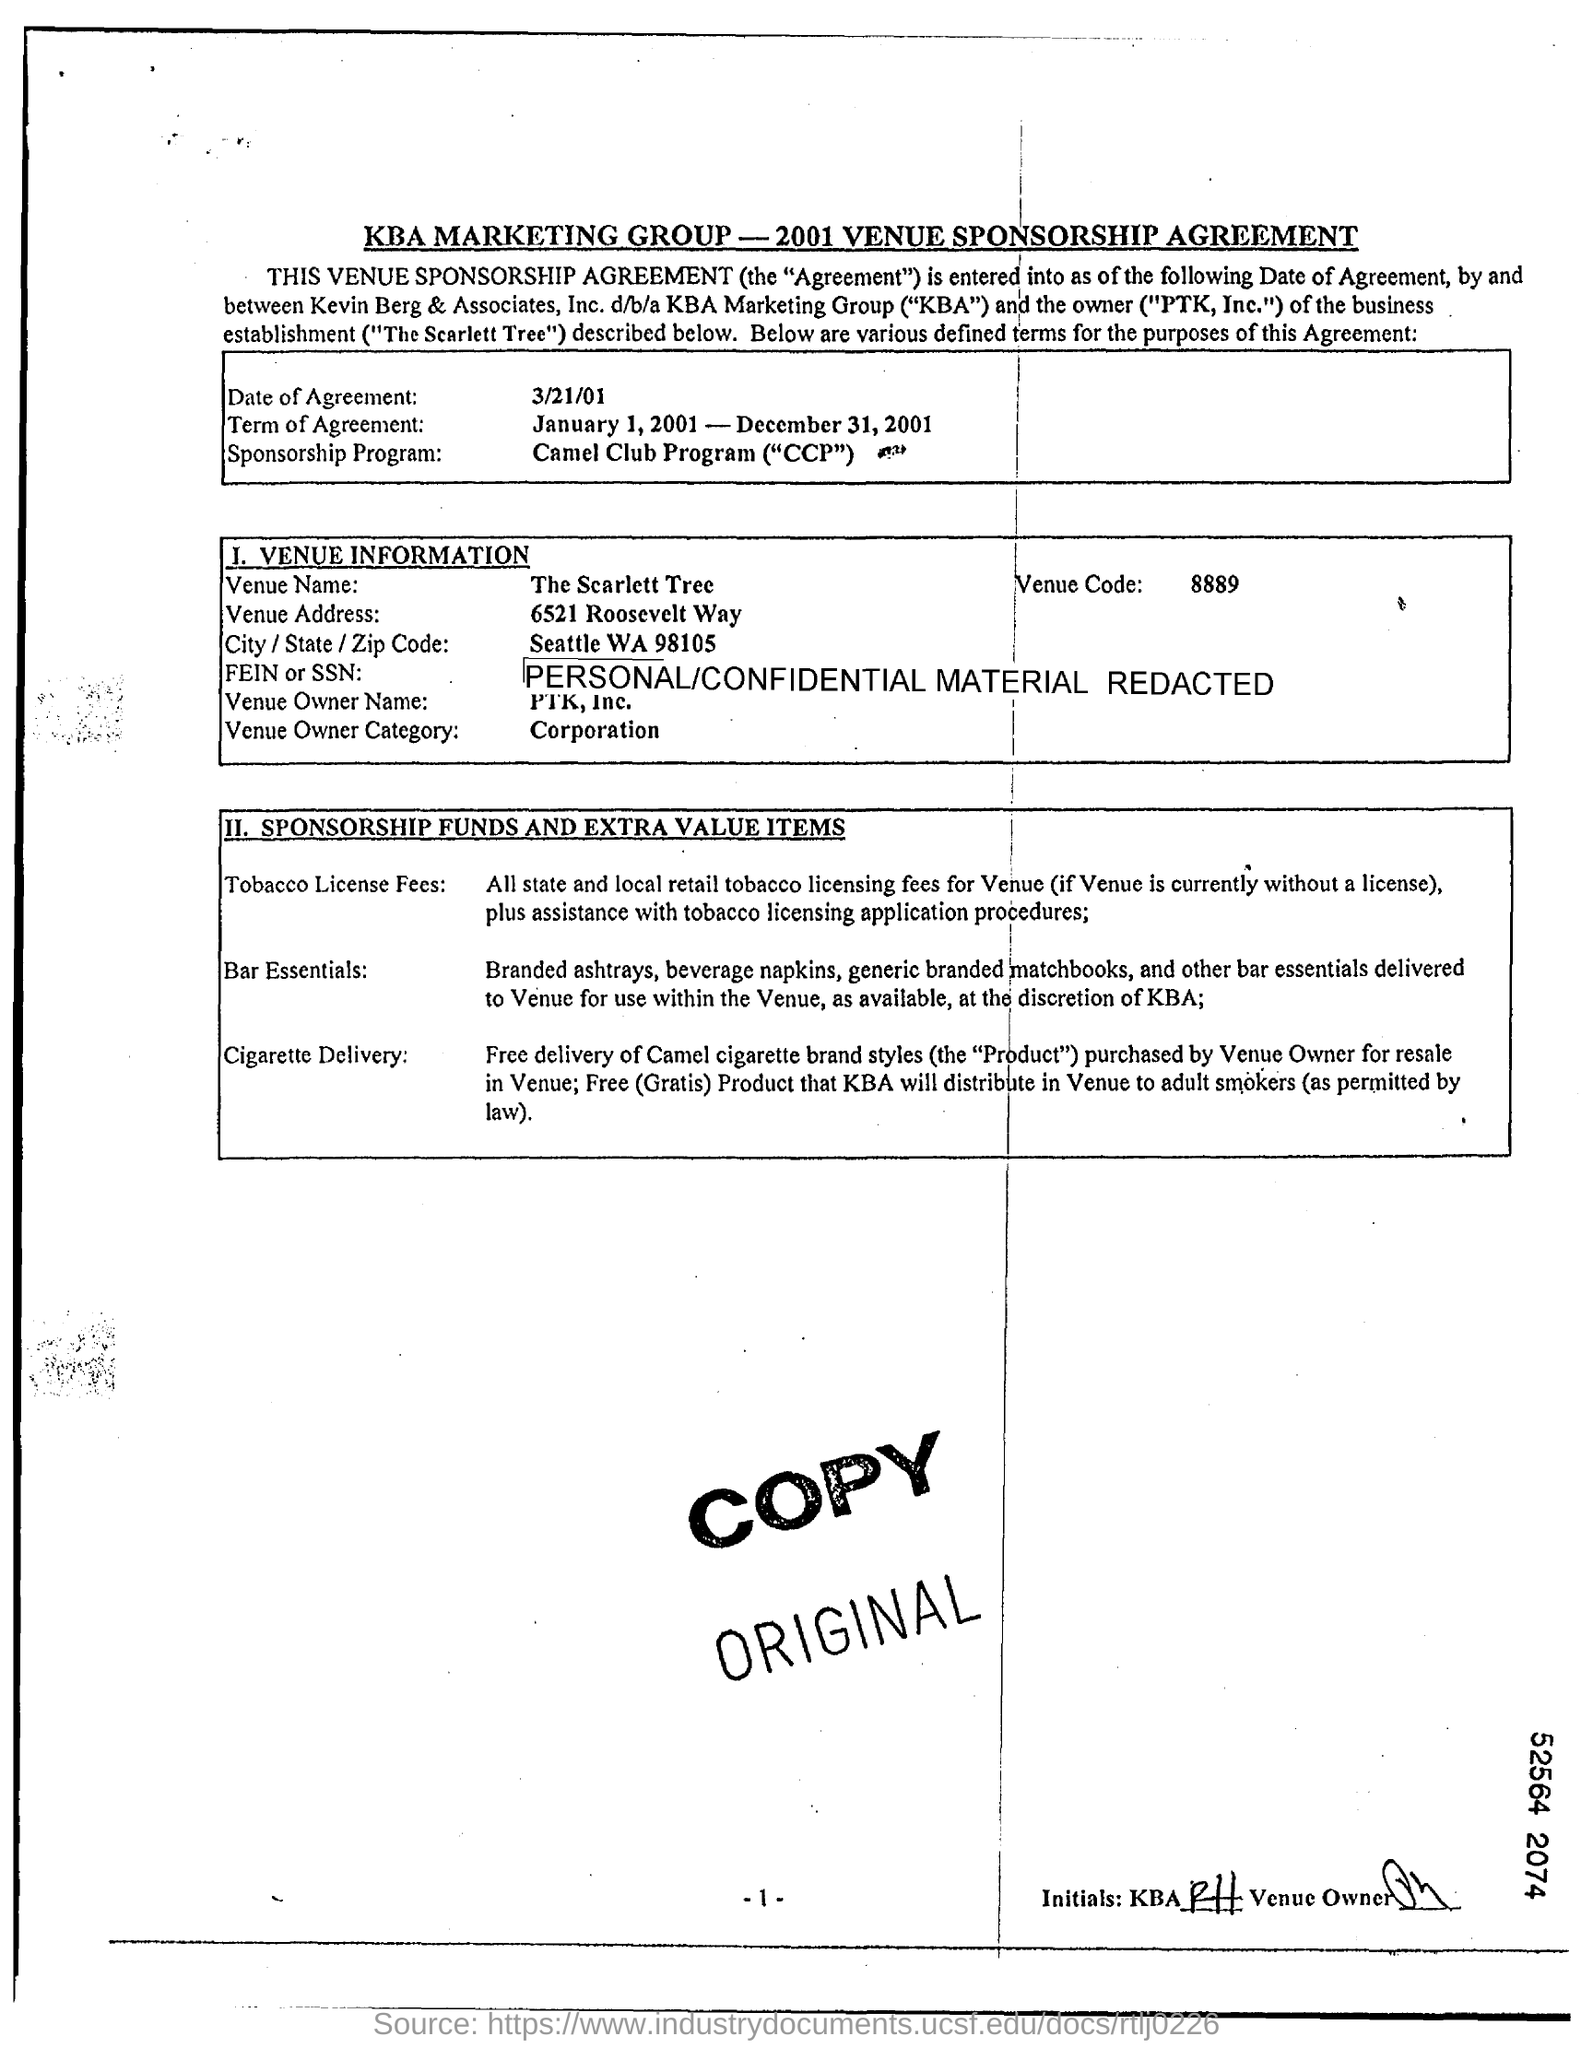When is Date of Agreement?
Give a very brief answer. 3/21/01. What is the Venue Name?
Give a very brief answer. The Scarlett Tree. What is the Venue Address?
Your response must be concise. 6521 Roosevelt Way. What is the Venue Owner Category?
Provide a succinct answer. Corporation. 